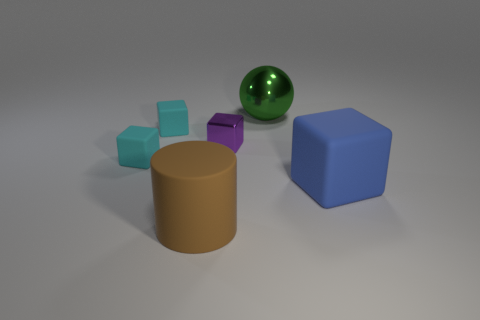Subtract all blue cylinders. Subtract all cyan cubes. How many cylinders are left? 1 Add 3 green spheres. How many objects exist? 9 Subtract all cylinders. How many objects are left? 5 Subtract 0 green cylinders. How many objects are left? 6 Subtract all tiny green balls. Subtract all large green metallic spheres. How many objects are left? 5 Add 5 large green shiny objects. How many large green shiny objects are left? 6 Add 3 blue matte blocks. How many blue matte blocks exist? 4 